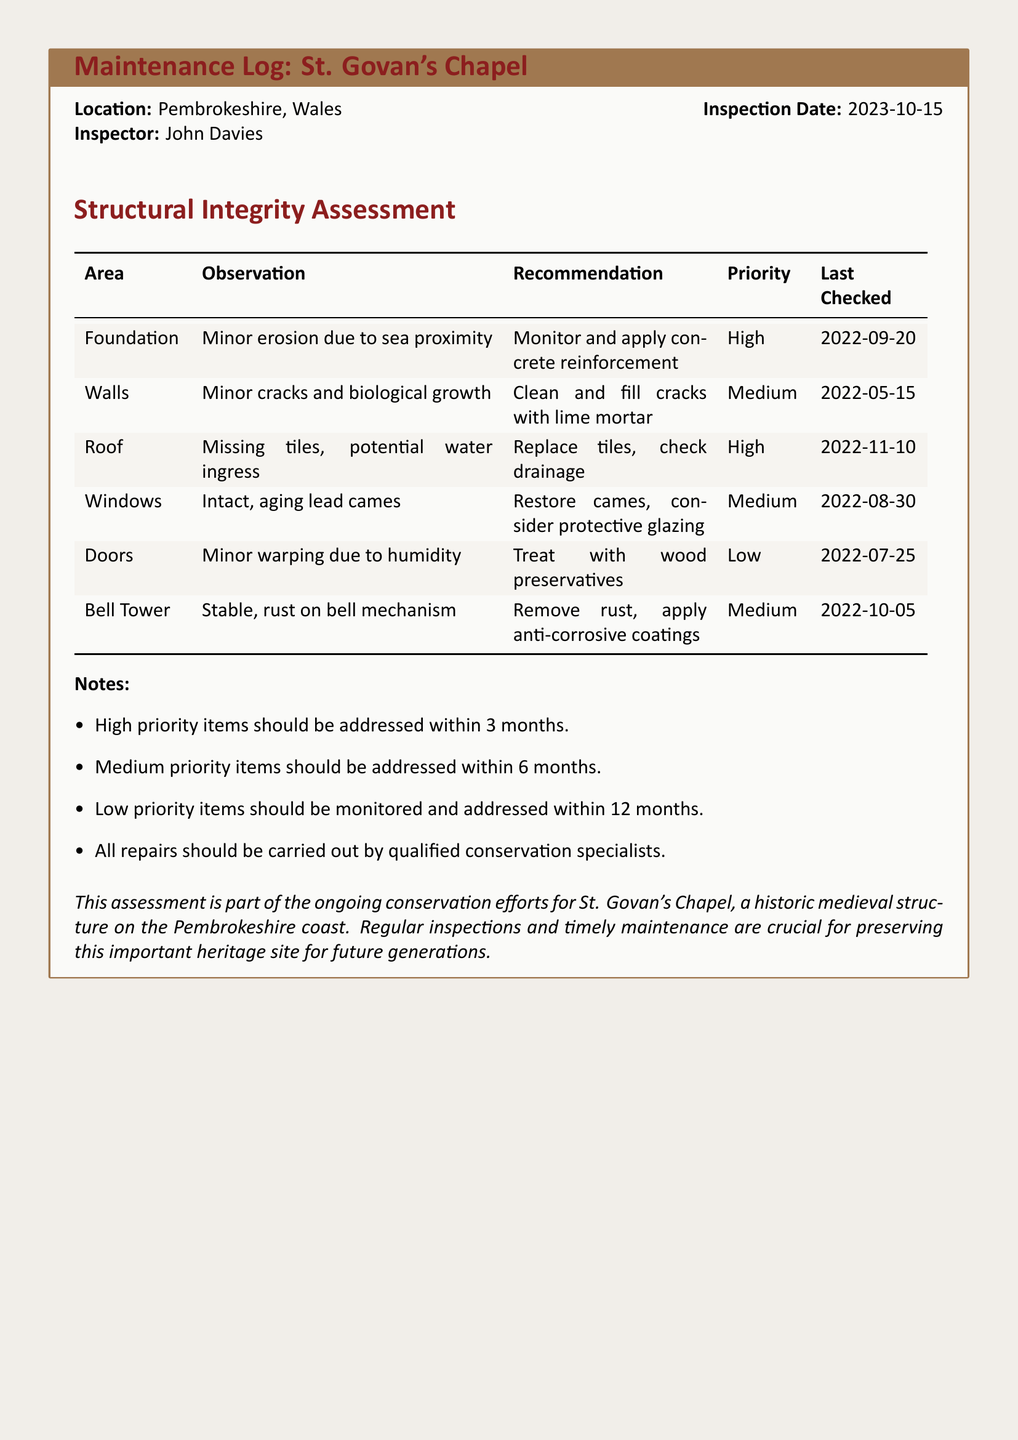What is the location of St. Govan's Chapel? The location is specified at the top of the document as Pembrokeshire, Wales.
Answer: Pembrokeshire, Wales Who conducted the inspection? The inspector's name is provided in the document as the person who performed the assessment.
Answer: John Davies What date was the inspection conducted? The inspection date is noted in the header of the maintenance log.
Answer: 2023-10-15 What is the highest priority observation? The document contains multiple observations with associated priority levels; the highest one is for the foundation area.
Answer: Minor erosion due to sea proximity How should medium priority items be addressed? The document specifies a timeline for addressing medium priority items in the notes section.
Answer: Within 6 months Which area requires tile replacement? The roof is noted as having missing tiles which necessitate replacement as per the observations section.
Answer: Roof What should be done to the aging lead cames? The recommendation for the windows area indicates restoration actions for the aging lead cames.
Answer: Restore cames What is the priority level for the doors? The priority level assigned to the doors is explicitly mentioned in the observations table.
Answer: Low What type of repairs should be carried out? The notes emphasize the qualifications required for the specialists who handle the repairs outlined in the document.
Answer: Qualified conservation specialists 